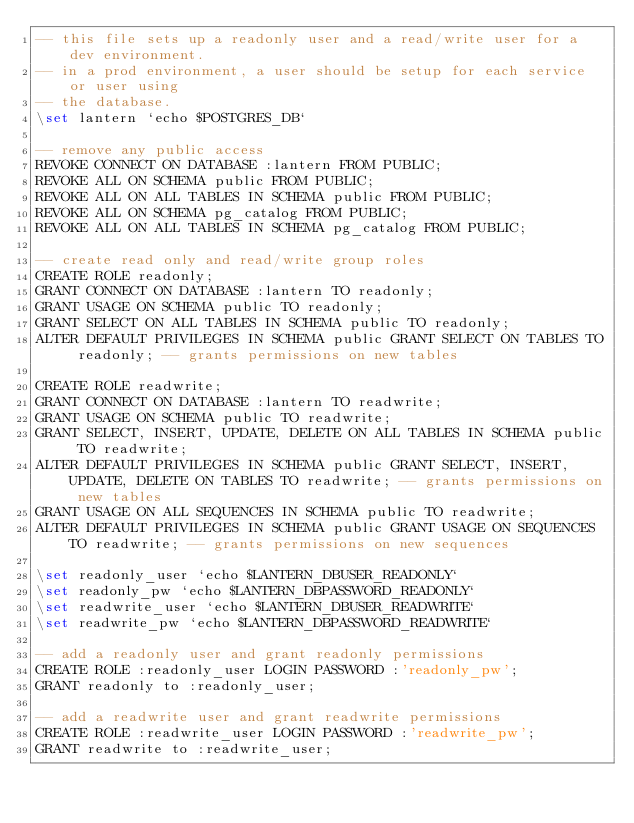<code> <loc_0><loc_0><loc_500><loc_500><_SQL_>-- this file sets up a readonly user and a read/write user for a dev environment.
-- in a prod environment, a user should be setup for each service or user using
-- the database.
\set lantern `echo $POSTGRES_DB`

-- remove any public access
REVOKE CONNECT ON DATABASE :lantern FROM PUBLIC;
REVOKE ALL ON SCHEMA public FROM PUBLIC;
REVOKE ALL ON ALL TABLES IN SCHEMA public FROM PUBLIC;
REVOKE ALL ON SCHEMA pg_catalog FROM PUBLIC;
REVOKE ALL ON ALL TABLES IN SCHEMA pg_catalog FROM PUBLIC;

-- create read only and read/write group roles
CREATE ROLE readonly;
GRANT CONNECT ON DATABASE :lantern TO readonly;
GRANT USAGE ON SCHEMA public TO readonly;
GRANT SELECT ON ALL TABLES IN SCHEMA public TO readonly;
ALTER DEFAULT PRIVILEGES IN SCHEMA public GRANT SELECT ON TABLES TO readonly; -- grants permissions on new tables

CREATE ROLE readwrite;
GRANT CONNECT ON DATABASE :lantern TO readwrite;
GRANT USAGE ON SCHEMA public TO readwrite;
GRANT SELECT, INSERT, UPDATE, DELETE ON ALL TABLES IN SCHEMA public TO readwrite;
ALTER DEFAULT PRIVILEGES IN SCHEMA public GRANT SELECT, INSERT, UPDATE, DELETE ON TABLES TO readwrite; -- grants permissions on new tables
GRANT USAGE ON ALL SEQUENCES IN SCHEMA public TO readwrite;
ALTER DEFAULT PRIVILEGES IN SCHEMA public GRANT USAGE ON SEQUENCES TO readwrite; -- grants permissions on new sequences

\set readonly_user `echo $LANTERN_DBUSER_READONLY`
\set readonly_pw `echo $LANTERN_DBPASSWORD_READONLY`
\set readwrite_user `echo $LANTERN_DBUSER_READWRITE`
\set readwrite_pw `echo $LANTERN_DBPASSWORD_READWRITE`

-- add a readonly user and grant readonly permissions
CREATE ROLE :readonly_user LOGIN PASSWORD :'readonly_pw';
GRANT readonly to :readonly_user;

-- add a readwrite user and grant readwrite permissions
CREATE ROLE :readwrite_user LOGIN PASSWORD :'readwrite_pw';
GRANT readwrite to :readwrite_user;</code> 